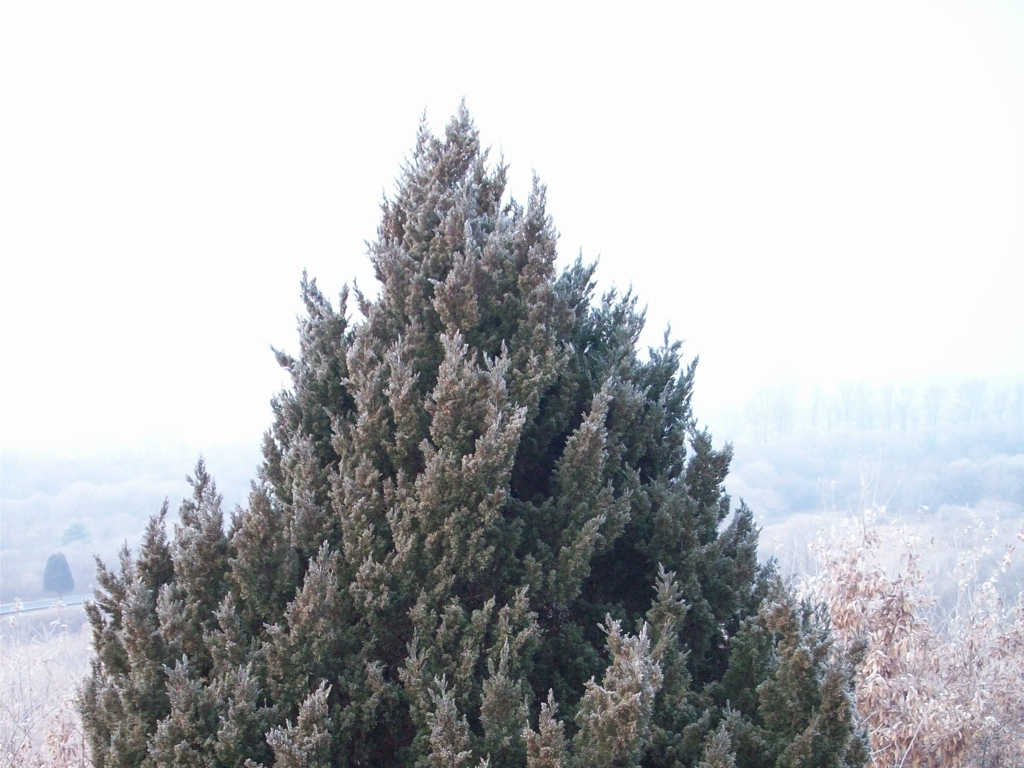Could you tell me more about the type of tree and why it's able to sustain frost? This tree is a type of evergreen, specifically a conifer, which are well-known for their ability to withstand cold conditions. Conifers have needles instead of broad leaves, which reduce the surface area and thus the amount of water they lose through transpiration. This adaptation, along with a waxy coating on the needles, helps them minimize moisture loss during frosty conditions, allowing them to sustain and thrive in cold climates. 